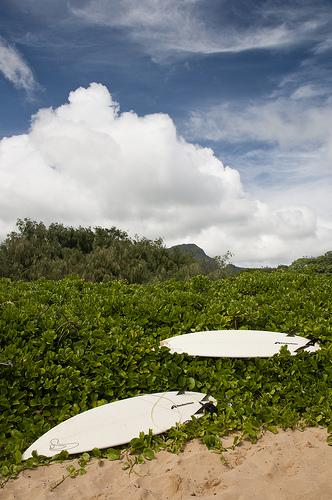Question: where was this picture taken?
Choices:
A. At a beach.
B. The elementary school I used to go to.
C. Outside.
D. In the car.
Answer with the letter. Answer: A Question: where is the sand?
Choices:
A. In the sandbox.
B. At the bottom of the photo.
C. Next to the pond.
D. On the volleyball court.
Answer with the letter. Answer: B Question: what color are the clouds?
Choices:
A. Gray.
B. Pink.
C. Blue.
D. White.
Answer with the letter. Answer: D Question: how many fins are on each surfboard?
Choices:
A. None.
B. Two.
C. One.
D. Three.
Answer with the letter. Answer: D 